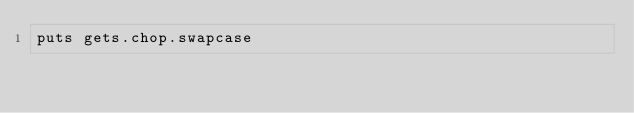Convert code to text. <code><loc_0><loc_0><loc_500><loc_500><_Ruby_>puts gets.chop.swapcase

</code> 